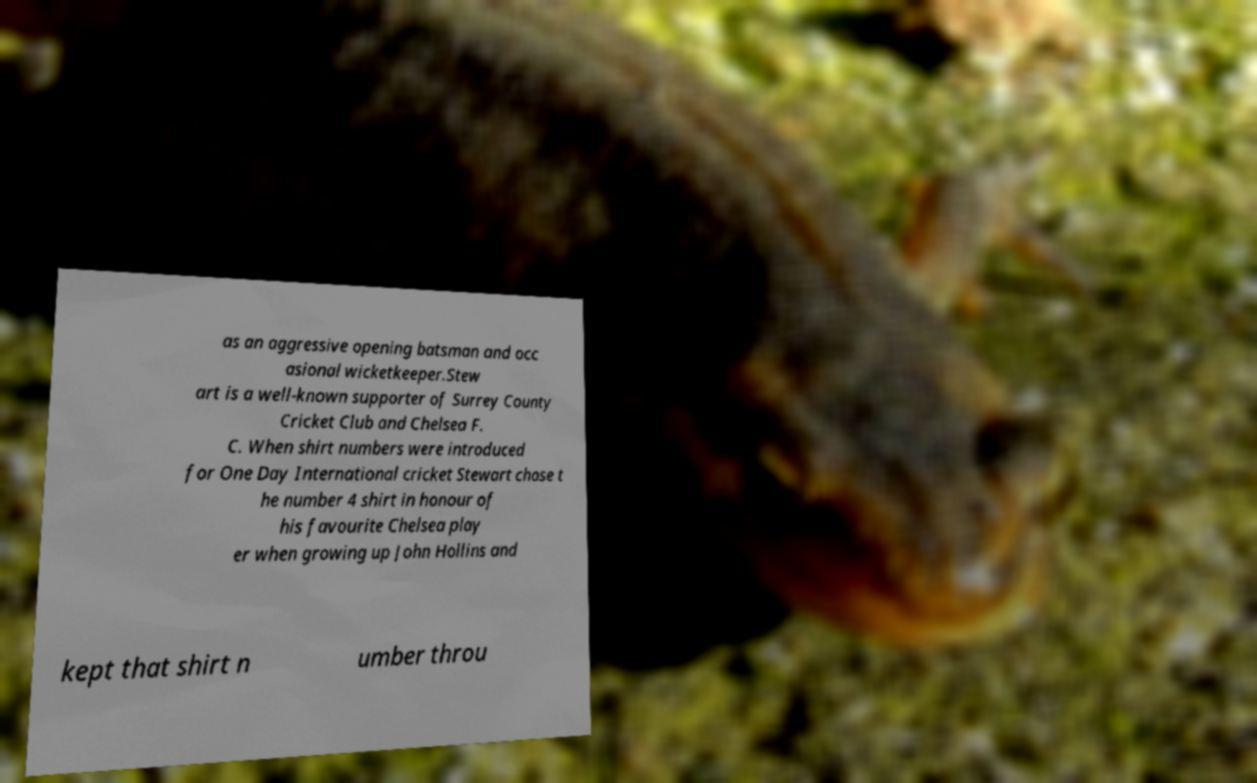There's text embedded in this image that I need extracted. Can you transcribe it verbatim? as an aggressive opening batsman and occ asional wicketkeeper.Stew art is a well-known supporter of Surrey County Cricket Club and Chelsea F. C. When shirt numbers were introduced for One Day International cricket Stewart chose t he number 4 shirt in honour of his favourite Chelsea play er when growing up John Hollins and kept that shirt n umber throu 